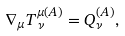<formula> <loc_0><loc_0><loc_500><loc_500>\nabla _ { \mu } T ^ { \mu ( A ) } _ { \, \nu } = Q ^ { ( A ) } _ { \nu } ,</formula> 